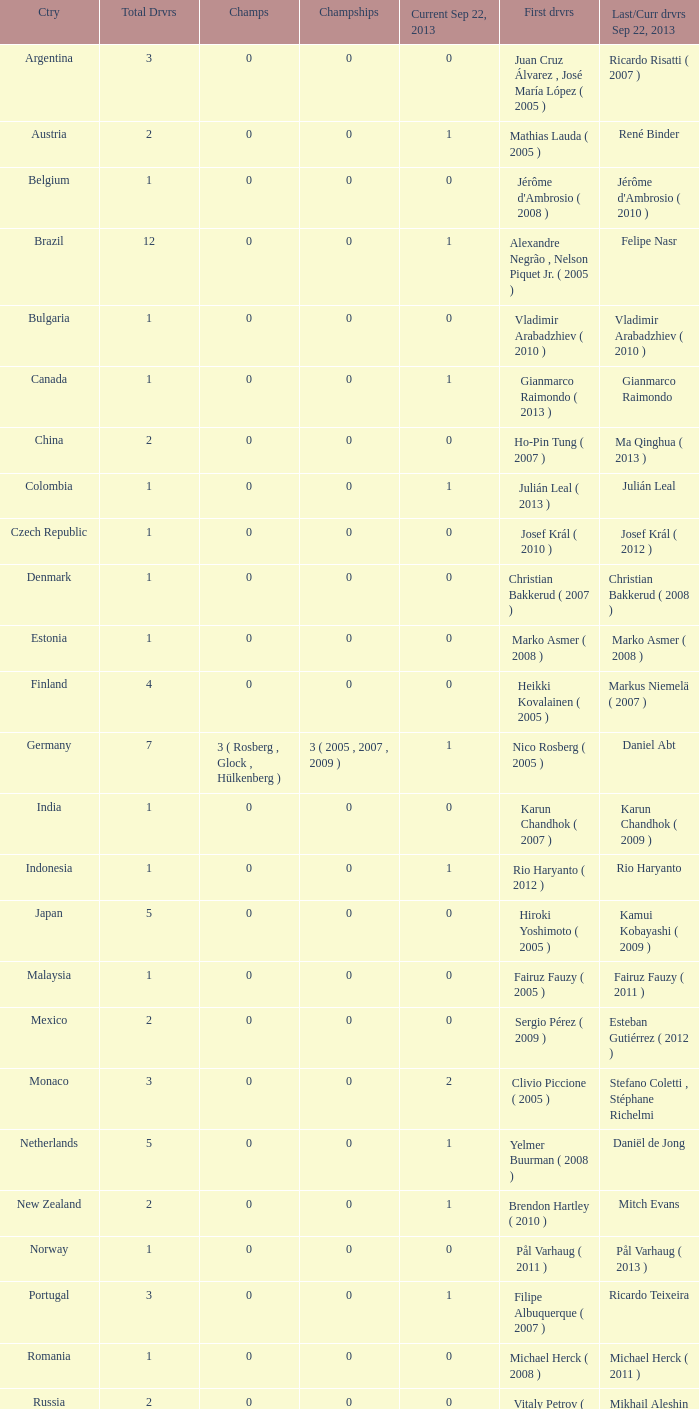How many entries are there for first driver for Canada? 1.0. 